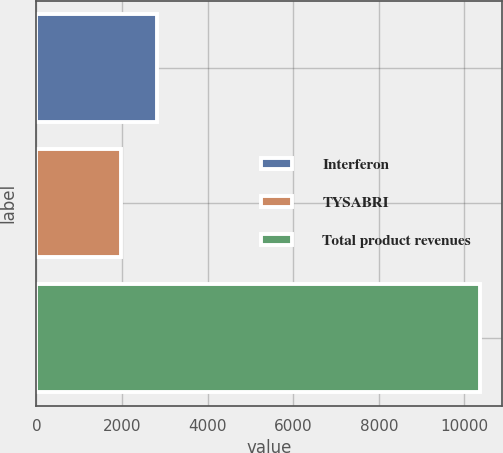Convert chart to OTSL. <chart><loc_0><loc_0><loc_500><loc_500><bar_chart><fcel>Interferon<fcel>TYSABRI<fcel>Total product revenues<nl><fcel>2811.26<fcel>1973.1<fcel>10354.7<nl></chart> 